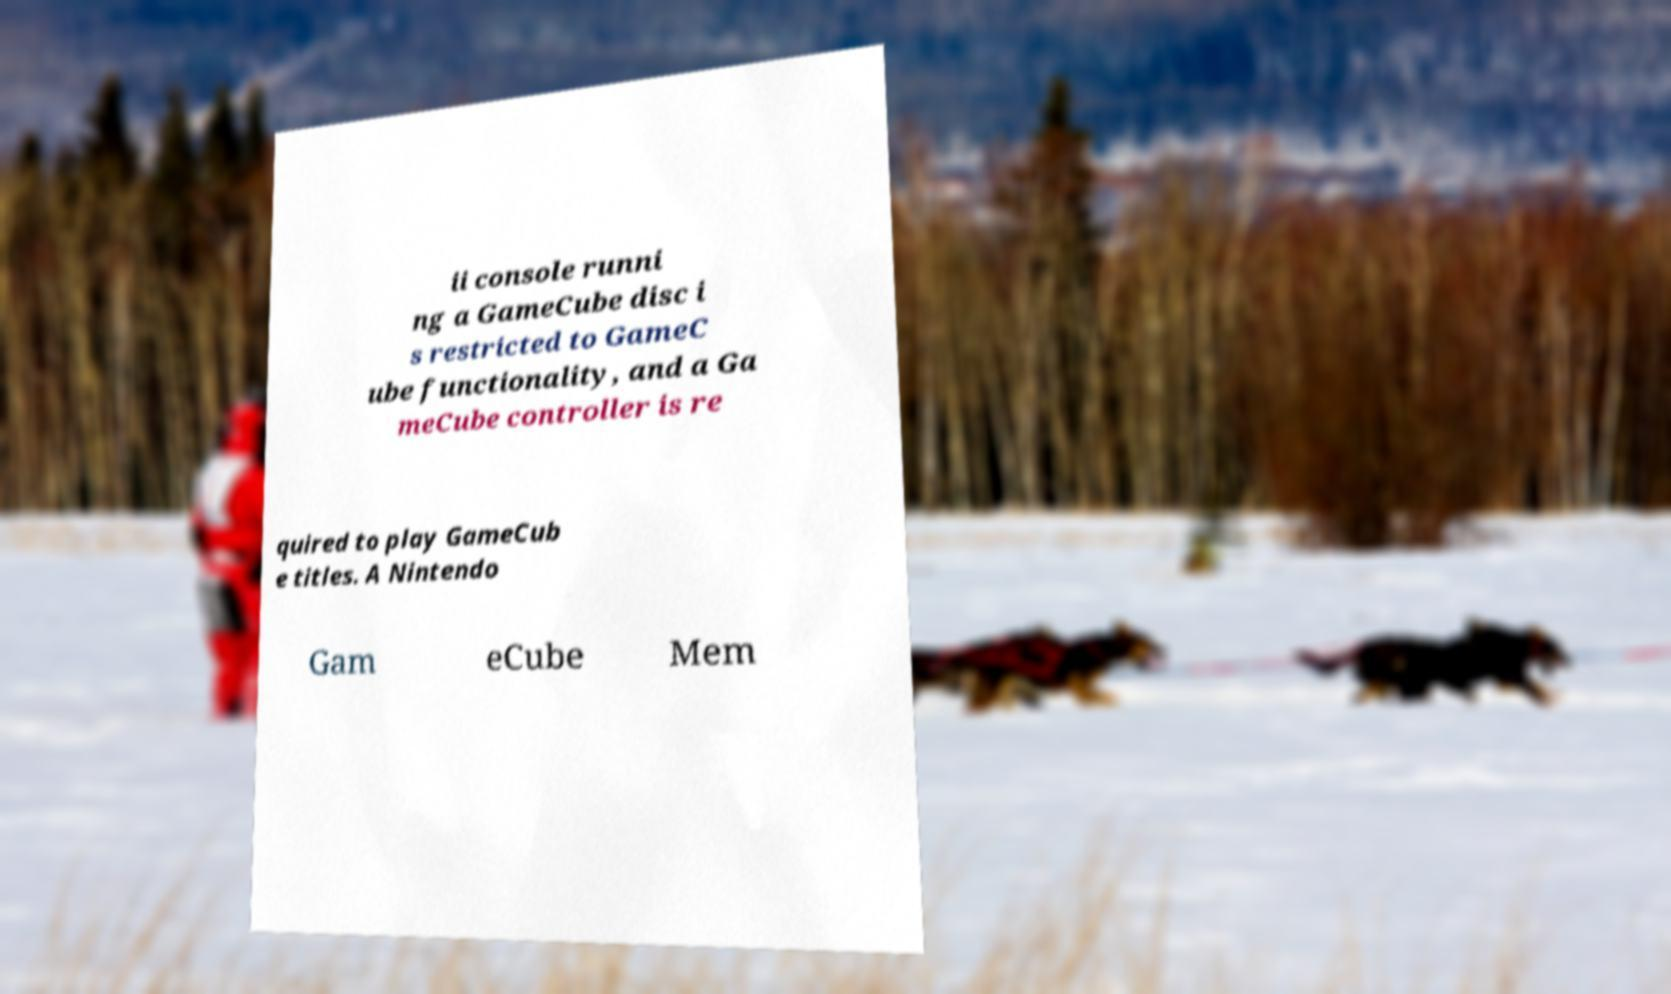There's text embedded in this image that I need extracted. Can you transcribe it verbatim? ii console runni ng a GameCube disc i s restricted to GameC ube functionality, and a Ga meCube controller is re quired to play GameCub e titles. A Nintendo Gam eCube Mem 